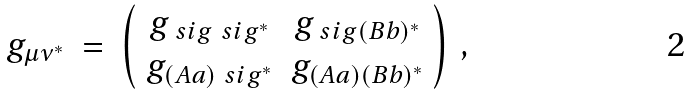<formula> <loc_0><loc_0><loc_500><loc_500>g _ { \mu \nu ^ { * } } \ & = \ \left ( \begin{array} { c c } g _ { \ s i g \ s i g ^ { * } } & g _ { \ s i g ( B b ) ^ { * } } \\ g _ { ( A a ) \ s i g ^ { * } } & g _ { ( A a ) ( B b ) ^ { * } } \end{array} \right ) \, ,</formula> 